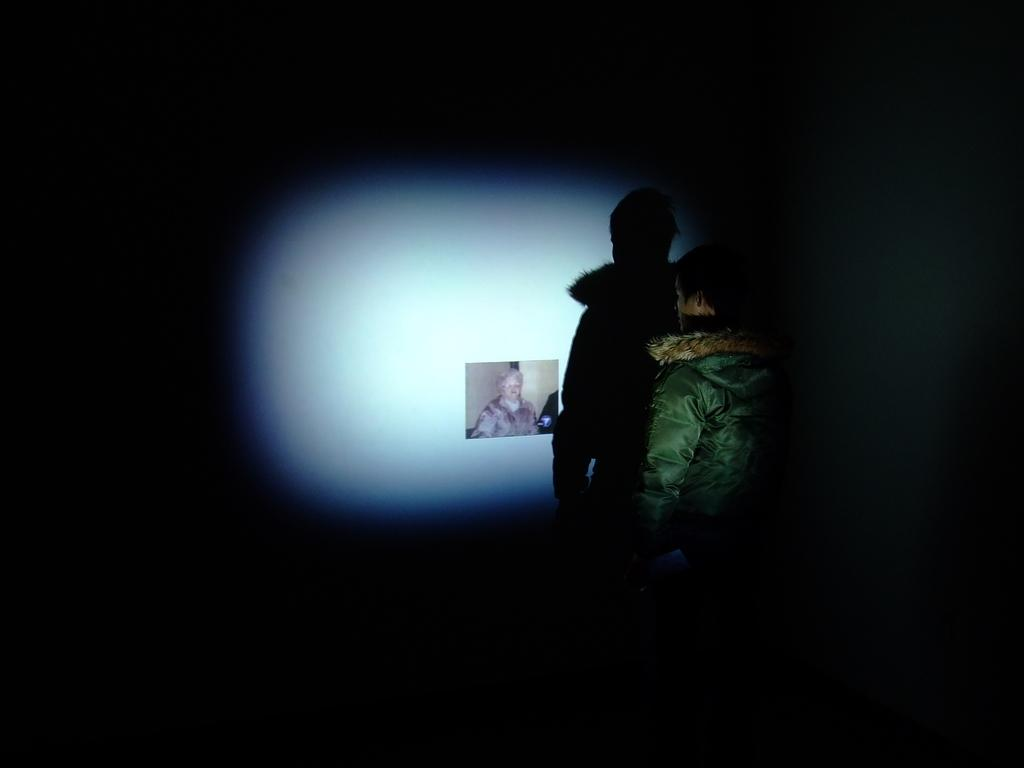What is the lighting condition in the image? The image was taken in the dark. Can you describe the person in the image? There is a person in the image, and they are wearing a jacket. Where is the person standing in the image? The person is standing in front of a wall. What is attached to the wall in the image? There is a photo attached to the wall. Did the person in the image experience an earthquake while taking the photo? There is no indication of an earthquake in the image, and it is not mentioned in the provided facts. 